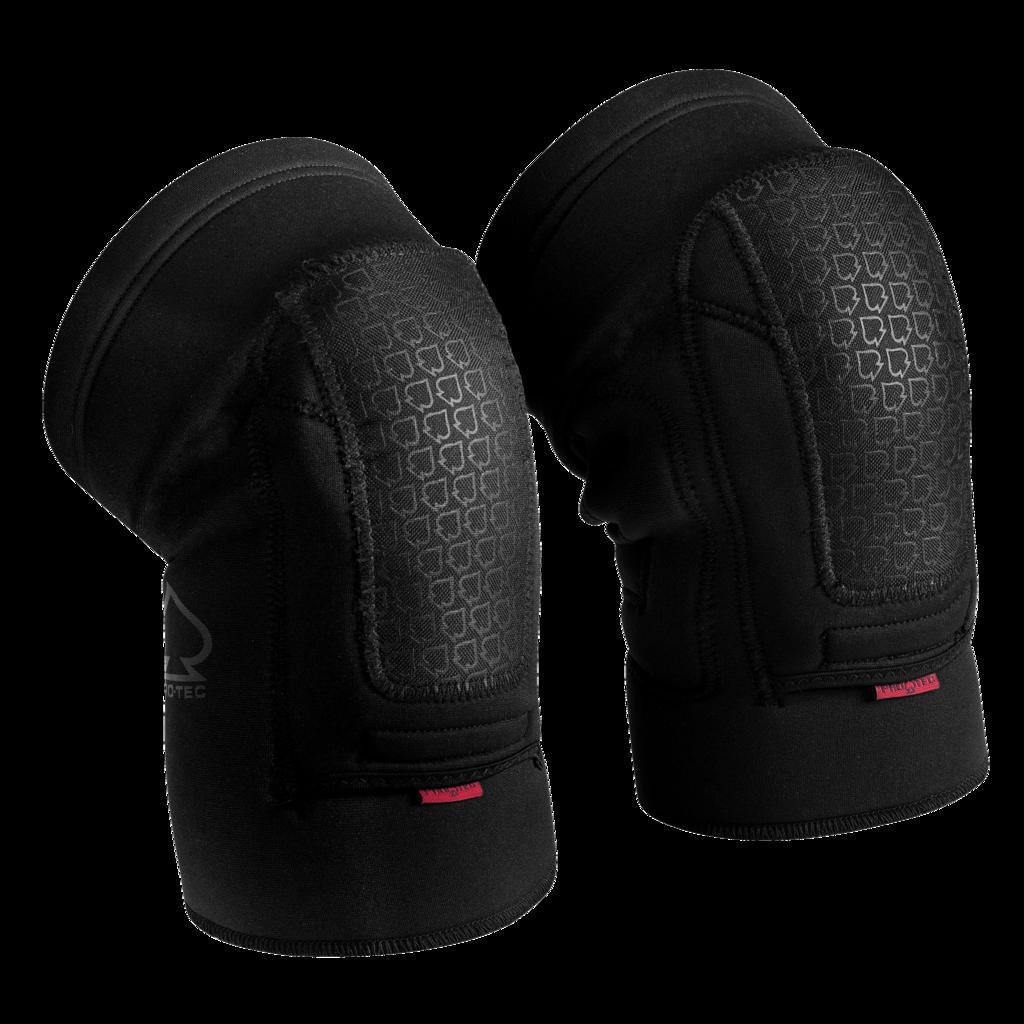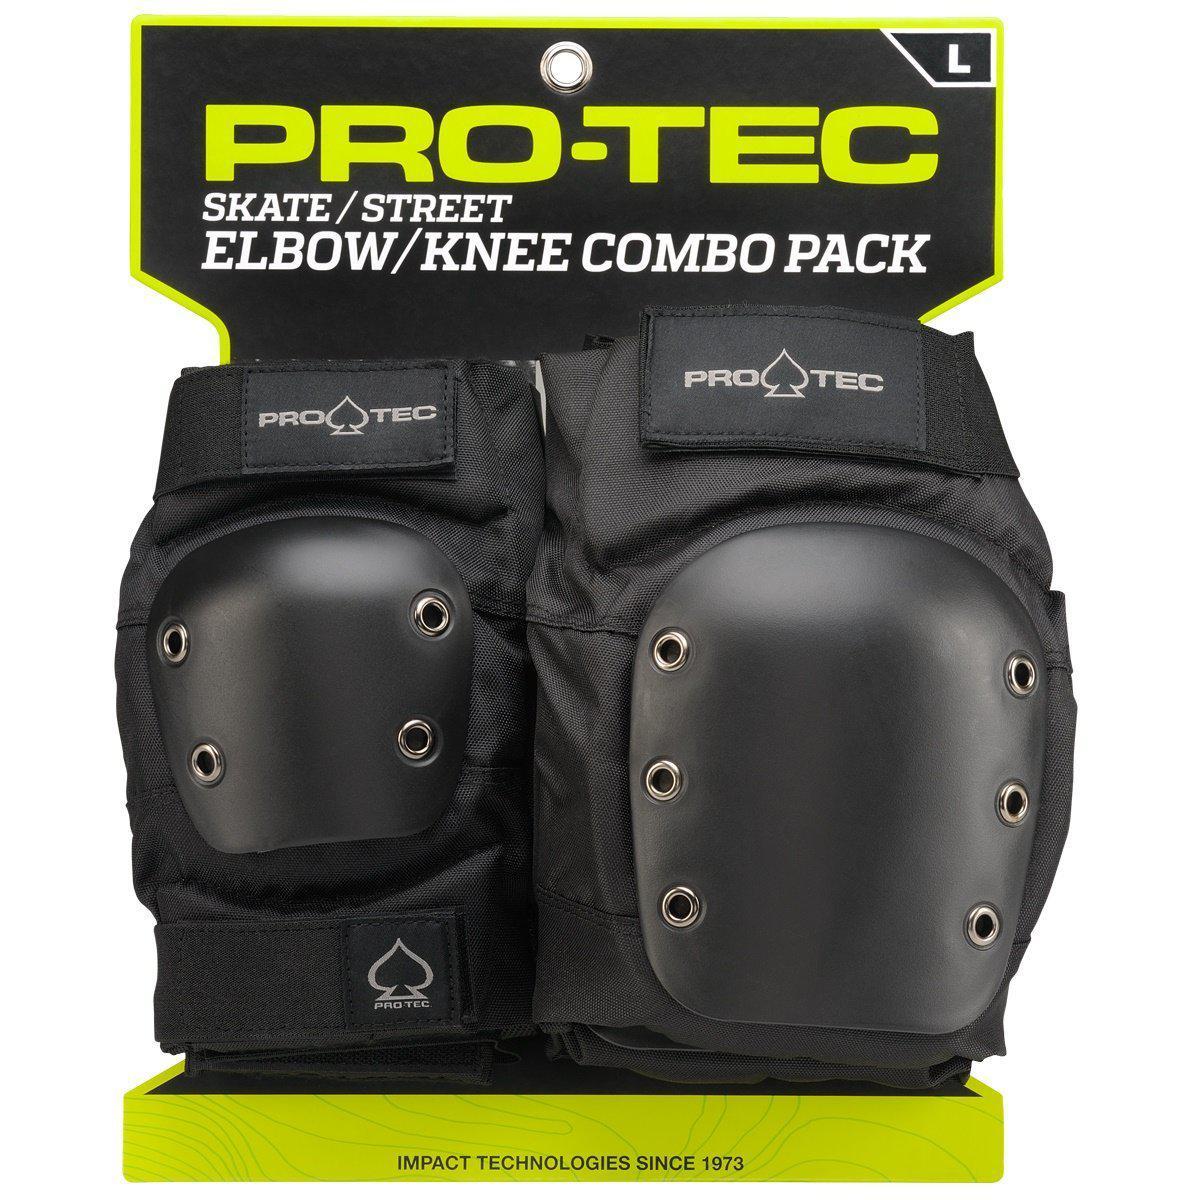The first image is the image on the left, the second image is the image on the right. For the images displayed, is the sentence "Both images contain a pair of all black knee pads" factually correct? Answer yes or no. Yes. The first image is the image on the left, the second image is the image on the right. Evaluate the accuracy of this statement regarding the images: "Both knee pads are facing to the right". Is it true? Answer yes or no. No. 